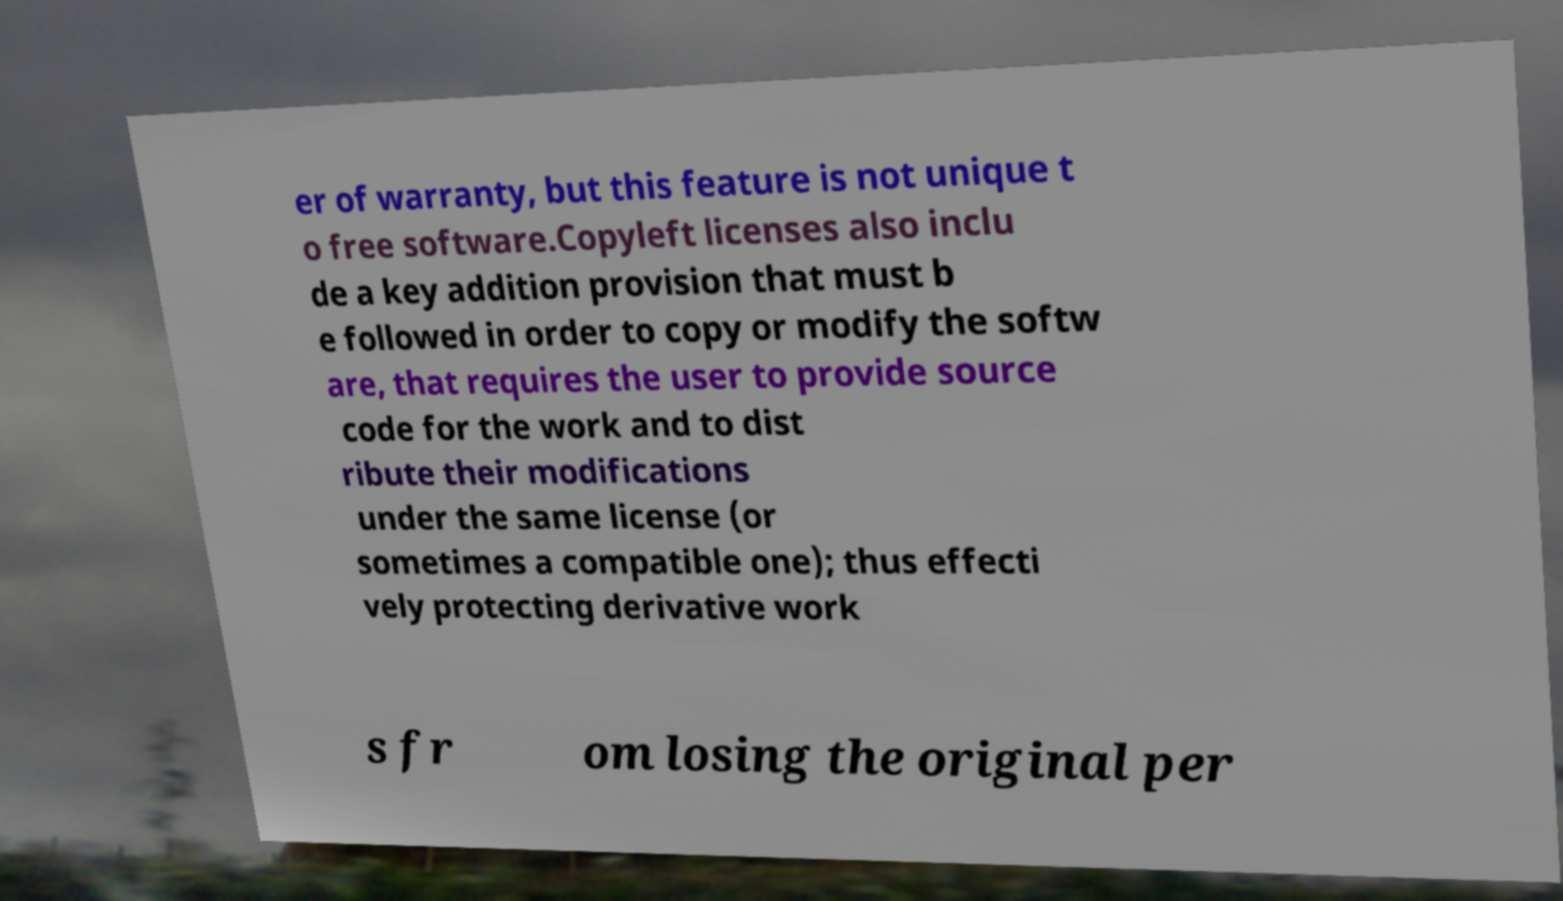Could you assist in decoding the text presented in this image and type it out clearly? er of warranty, but this feature is not unique t o free software.Copyleft licenses also inclu de a key addition provision that must b e followed in order to copy or modify the softw are, that requires the user to provide source code for the work and to dist ribute their modifications under the same license (or sometimes a compatible one); thus effecti vely protecting derivative work s fr om losing the original per 